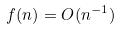Convert formula to latex. <formula><loc_0><loc_0><loc_500><loc_500>f ( n ) = O ( n ^ { - 1 } )</formula> 